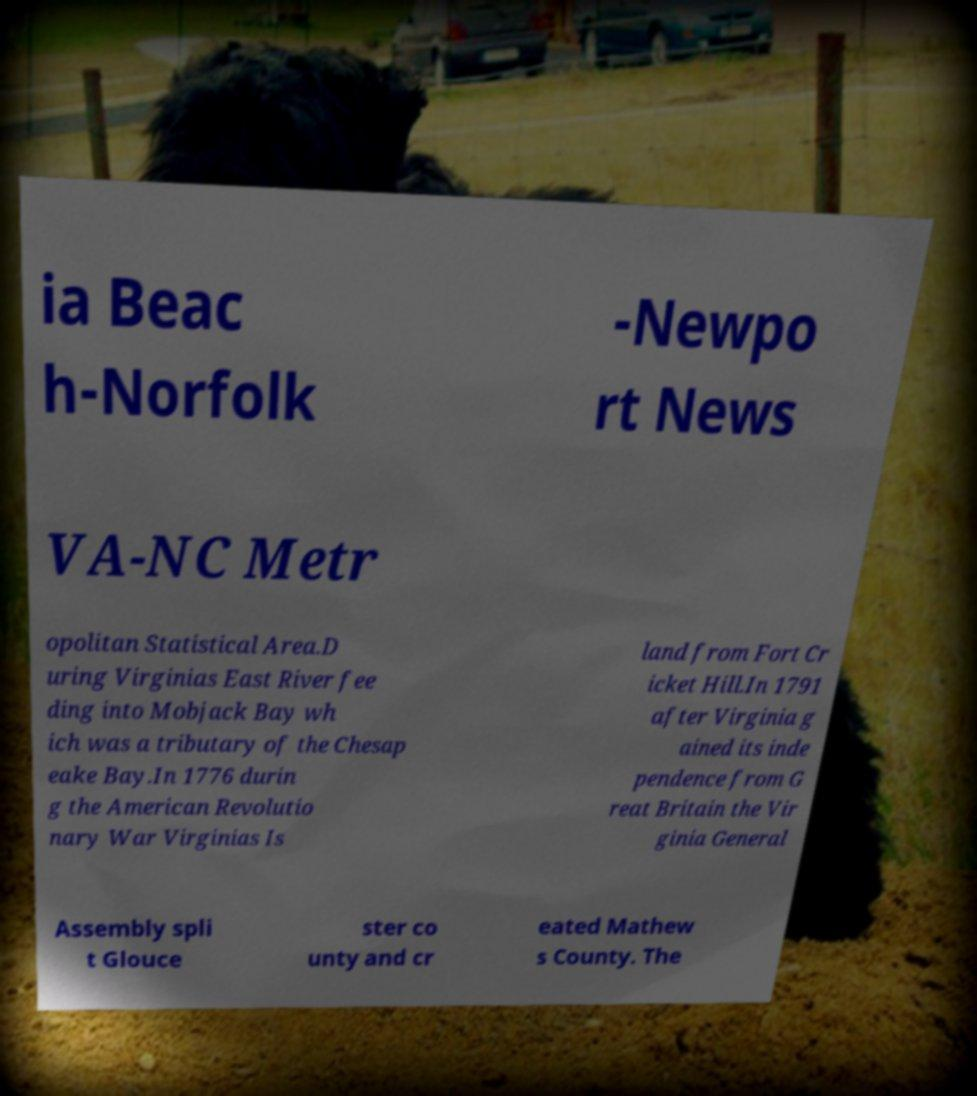Could you extract and type out the text from this image? ia Beac h-Norfolk -Newpo rt News VA-NC Metr opolitan Statistical Area.D uring Virginias East River fee ding into Mobjack Bay wh ich was a tributary of the Chesap eake Bay.In 1776 durin g the American Revolutio nary War Virginias Is land from Fort Cr icket Hill.In 1791 after Virginia g ained its inde pendence from G reat Britain the Vir ginia General Assembly spli t Glouce ster co unty and cr eated Mathew s County. The 